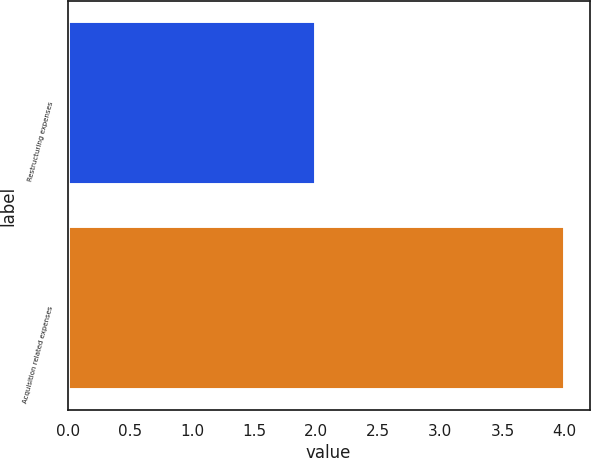Convert chart. <chart><loc_0><loc_0><loc_500><loc_500><bar_chart><fcel>Restructuring expenses<fcel>Acquisition related expenses<nl><fcel>2<fcel>4<nl></chart> 